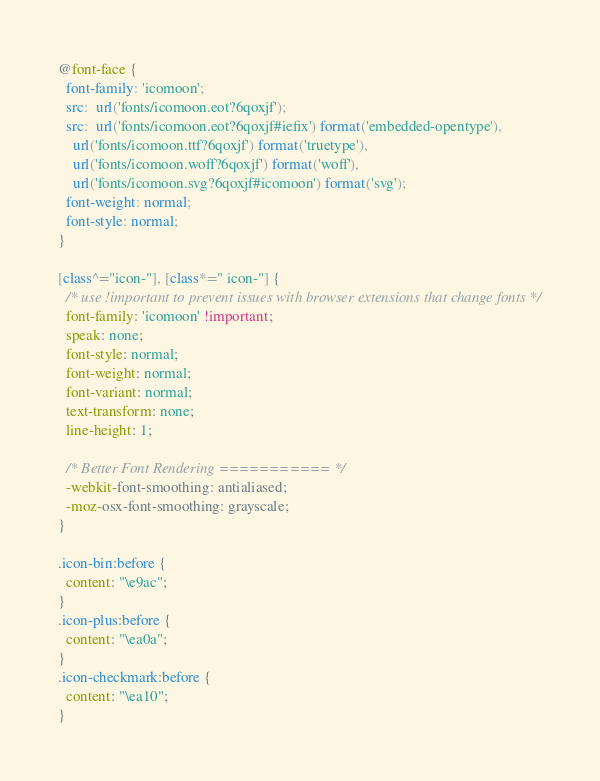Convert code to text. <code><loc_0><loc_0><loc_500><loc_500><_CSS_>@font-face {
  font-family: 'icomoon';
  src:  url('fonts/icomoon.eot?6qoxjf');
  src:  url('fonts/icomoon.eot?6qoxjf#iefix') format('embedded-opentype'),
    url('fonts/icomoon.ttf?6qoxjf') format('truetype'),
    url('fonts/icomoon.woff?6qoxjf') format('woff'),
    url('fonts/icomoon.svg?6qoxjf#icomoon') format('svg');
  font-weight: normal;
  font-style: normal;
}

[class^="icon-"], [class*=" icon-"] {
  /* use !important to prevent issues with browser extensions that change fonts */
  font-family: 'icomoon' !important;
  speak: none;
  font-style: normal;
  font-weight: normal;
  font-variant: normal;
  text-transform: none;
  line-height: 1;

  /* Better Font Rendering =========== */
  -webkit-font-smoothing: antialiased;
  -moz-osx-font-smoothing: grayscale;
}

.icon-bin:before {
  content: "\e9ac";
}
.icon-plus:before {
  content: "\ea0a";
}
.icon-checkmark:before {
  content: "\ea10";
}
</code> 